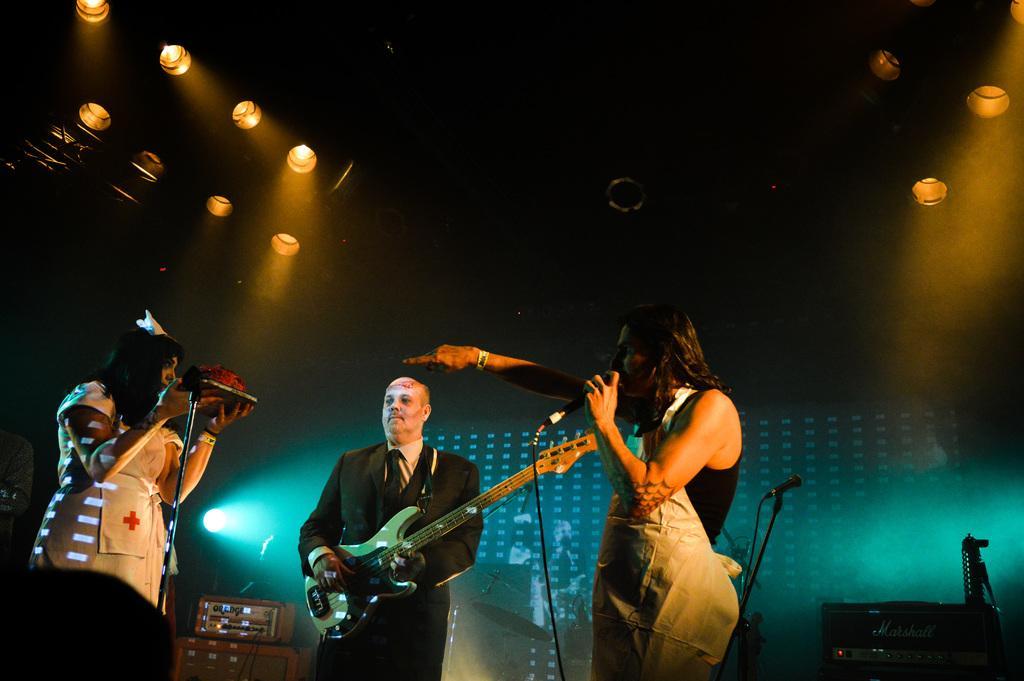Describe this image in one or two sentences. At the top we can see lights. Here we can see persons standing in front of a mike singing and playing guitar. This is an electronic device. 